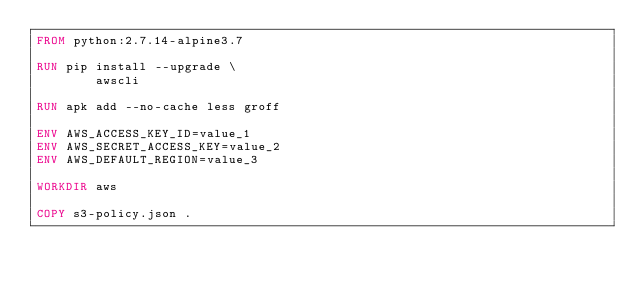<code> <loc_0><loc_0><loc_500><loc_500><_Dockerfile_>FROM python:2.7.14-alpine3.7

RUN pip install --upgrade \
        awscli

RUN apk add --no-cache less groff

ENV AWS_ACCESS_KEY_ID=value_1
ENV AWS_SECRET_ACCESS_KEY=value_2
ENV AWS_DEFAULT_REGION=value_3

WORKDIR aws

COPY s3-policy.json .

</code> 